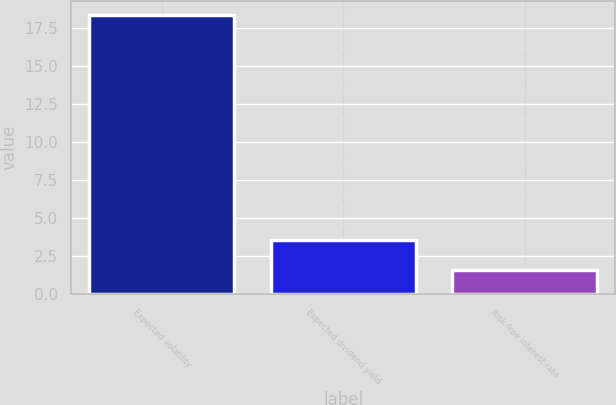<chart> <loc_0><loc_0><loc_500><loc_500><bar_chart><fcel>Expected volatility<fcel>Expected dividend yield<fcel>Risk-free interest rate<nl><fcel>18.4<fcel>3.6<fcel>1.6<nl></chart> 